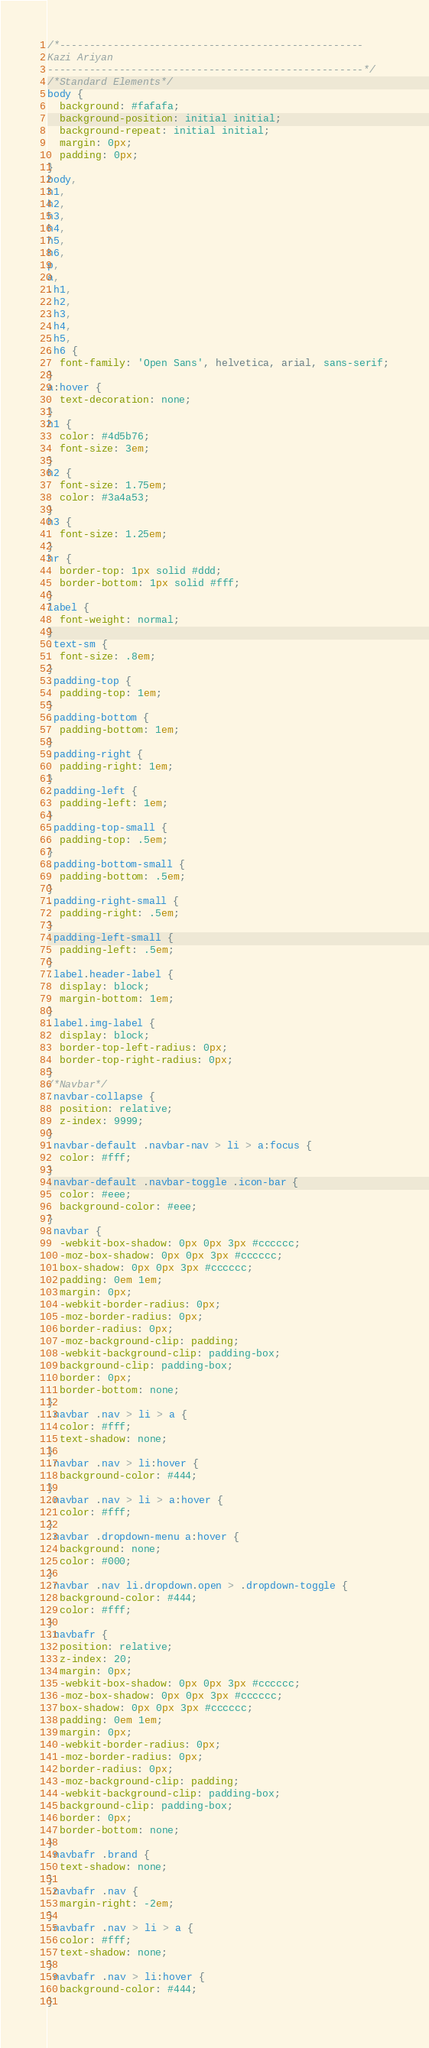Convert code to text. <code><loc_0><loc_0><loc_500><loc_500><_CSS_>/*---------------------------------------------------
Kazi Ariyan
-----------------------------------------------------*/
/*Standard Elements*/
body {
  background: #fafafa;
  background-position: initial initial;
  background-repeat: initial initial;
  margin: 0px;
  padding: 0px;
}
body,
h1,
h2,
h3,
h4,
h5,
h6,
p,
a,
.h1,
.h2,
.h3,
.h4,
.h5,
.h6 {
  font-family: 'Open Sans', helvetica, arial, sans-serif;
}
a:hover {
  text-decoration: none;
}
h1 {
  color: #4d5b76;
  font-size: 3em;
}
h2 {
  font-size: 1.75em;
  color: #3a4a53;
}
h3 {
  font-size: 1.25em;
}
hr {
  border-top: 1px solid #ddd;
  border-bottom: 1px solid #fff;
}
label {
  font-weight: normal;
}
.text-sm {
  font-size: .8em;
}
.padding-top {
  padding-top: 1em;
}
.padding-bottom {
  padding-bottom: 1em;
}
.padding-right {
  padding-right: 1em;
}
.padding-left {
  padding-left: 1em;
}
.padding-top-small {
  padding-top: .5em;
}
.padding-bottom-small {
  padding-bottom: .5em;
}
.padding-right-small {
  padding-right: .5em;
}
.padding-left-small {
  padding-left: .5em;
}
.label.header-label {
  display: block;
  margin-bottom: 1em;
}
.label.img-label {
  display: block;
  border-top-left-radius: 0px;
  border-top-right-radius: 0px;
}
/*Navbar*/
.navbar-collapse {
  position: relative;
  z-index: 9999;
}
.navbar-default .navbar-nav > li > a:focus {
  color: #fff;
}
.navbar-default .navbar-toggle .icon-bar {
  color: #eee;
  background-color: #eee;
}
.navbar {
  -webkit-box-shadow: 0px 0px 3px #cccccc;
  -moz-box-shadow: 0px 0px 3px #cccccc;
  box-shadow: 0px 0px 3px #cccccc;
  padding: 0em 1em;
  margin: 0px;
  -webkit-border-radius: 0px;
  -moz-border-radius: 0px;
  border-radius: 0px;
  -moz-background-clip: padding;
  -webkit-background-clip: padding-box;
  background-clip: padding-box;
  border: 0px;
  border-bottom: none;
}
.navbar .nav > li > a {
  color: #fff;
  text-shadow: none;
}
.navbar .nav > li:hover {
  background-color: #444;
}
.navbar .nav > li > a:hover {
  color: #fff;
}
.navbar .dropdown-menu a:hover {
  background: none;
  color: #000;
}
.navbar .nav li.dropdown.open > .dropdown-toggle {
  background-color: #444;
  color: #fff;
}
.navbafr {
  position: relative;
  z-index: 20;
  margin: 0px;
  -webkit-box-shadow: 0px 0px 3px #cccccc;
  -moz-box-shadow: 0px 0px 3px #cccccc;
  box-shadow: 0px 0px 3px #cccccc;
  padding: 0em 1em;
  margin: 0px;
  -webkit-border-radius: 0px;
  -moz-border-radius: 0px;
  border-radius: 0px;
  -moz-background-clip: padding;
  -webkit-background-clip: padding-box;
  background-clip: padding-box;
  border: 0px;
  border-bottom: none;
}
.navbafr .brand {
  text-shadow: none;
}
.navbafr .nav {
  margin-right: -2em;
}
.navbafr .nav > li > a {
  color: #fff;
  text-shadow: none;
}
.navbafr .nav > li:hover {
  background-color: #444;
}</code> 